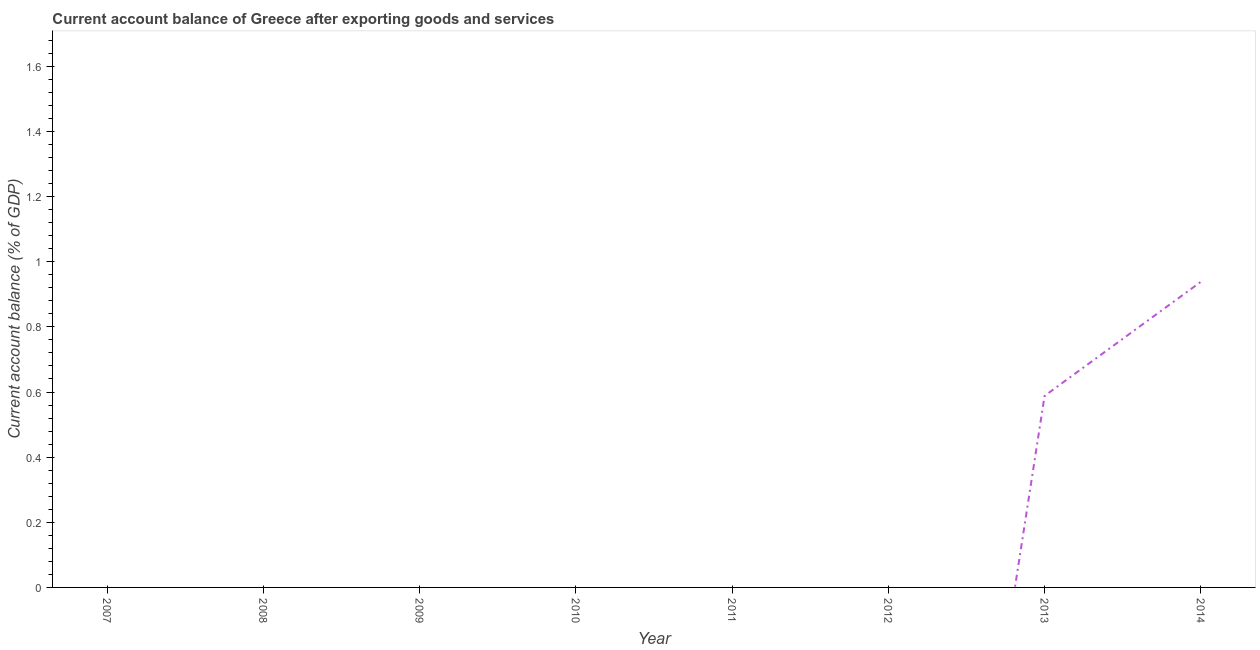What is the current account balance in 2014?
Offer a terse response. 0.94. Across all years, what is the maximum current account balance?
Provide a succinct answer. 0.94. What is the sum of the current account balance?
Your response must be concise. 1.53. What is the average current account balance per year?
Ensure brevity in your answer.  0.19. In how many years, is the current account balance greater than 1.36 %?
Offer a very short reply. 0. What is the difference between the highest and the lowest current account balance?
Offer a very short reply. 0.94. Does the current account balance monotonically increase over the years?
Your answer should be compact. No. How many years are there in the graph?
Provide a short and direct response. 8. What is the difference between two consecutive major ticks on the Y-axis?
Your answer should be very brief. 0.2. Are the values on the major ticks of Y-axis written in scientific E-notation?
Ensure brevity in your answer.  No. Does the graph contain any zero values?
Make the answer very short. Yes. What is the title of the graph?
Provide a short and direct response. Current account balance of Greece after exporting goods and services. What is the label or title of the Y-axis?
Your answer should be compact. Current account balance (% of GDP). What is the Current account balance (% of GDP) of 2007?
Make the answer very short. 0. What is the Current account balance (% of GDP) in 2008?
Your response must be concise. 0. What is the Current account balance (% of GDP) in 2010?
Ensure brevity in your answer.  0. What is the Current account balance (% of GDP) of 2012?
Ensure brevity in your answer.  0. What is the Current account balance (% of GDP) of 2013?
Your response must be concise. 0.59. What is the Current account balance (% of GDP) of 2014?
Make the answer very short. 0.94. What is the difference between the Current account balance (% of GDP) in 2013 and 2014?
Keep it short and to the point. -0.35. What is the ratio of the Current account balance (% of GDP) in 2013 to that in 2014?
Provide a short and direct response. 0.63. 